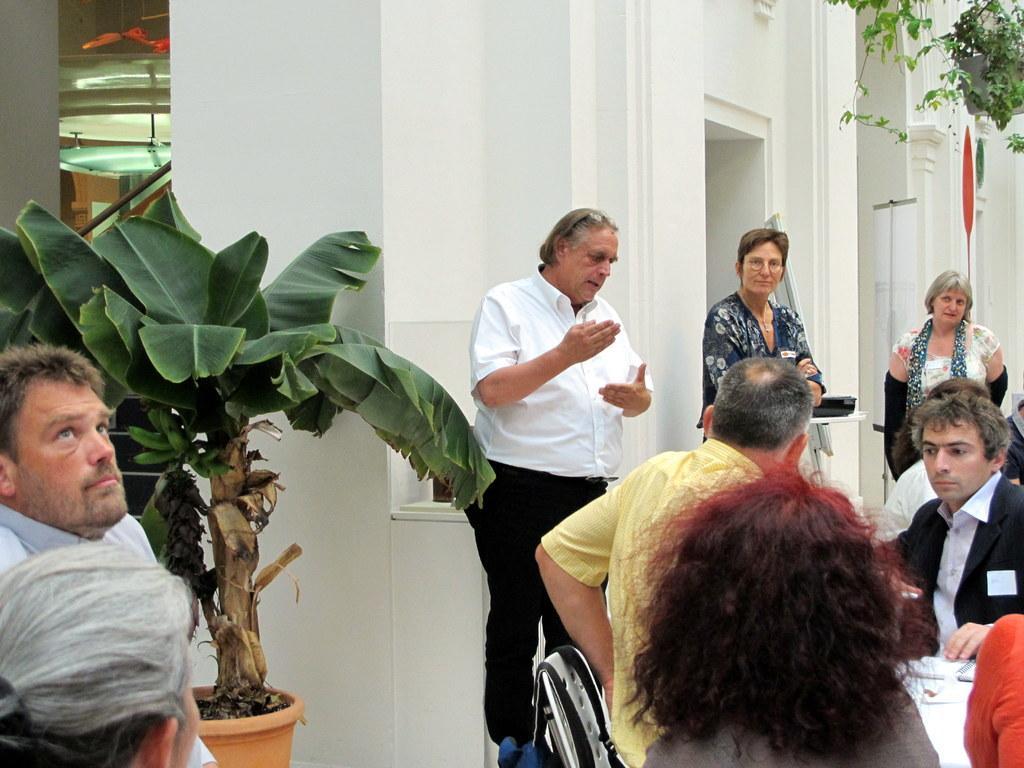In one or two sentences, can you explain what this image depicts? In this image there are a few people sitting in chairs, in front of them on the table there are some objects, behind them there are a few people standing, behind them there is a plant and there is a building. 